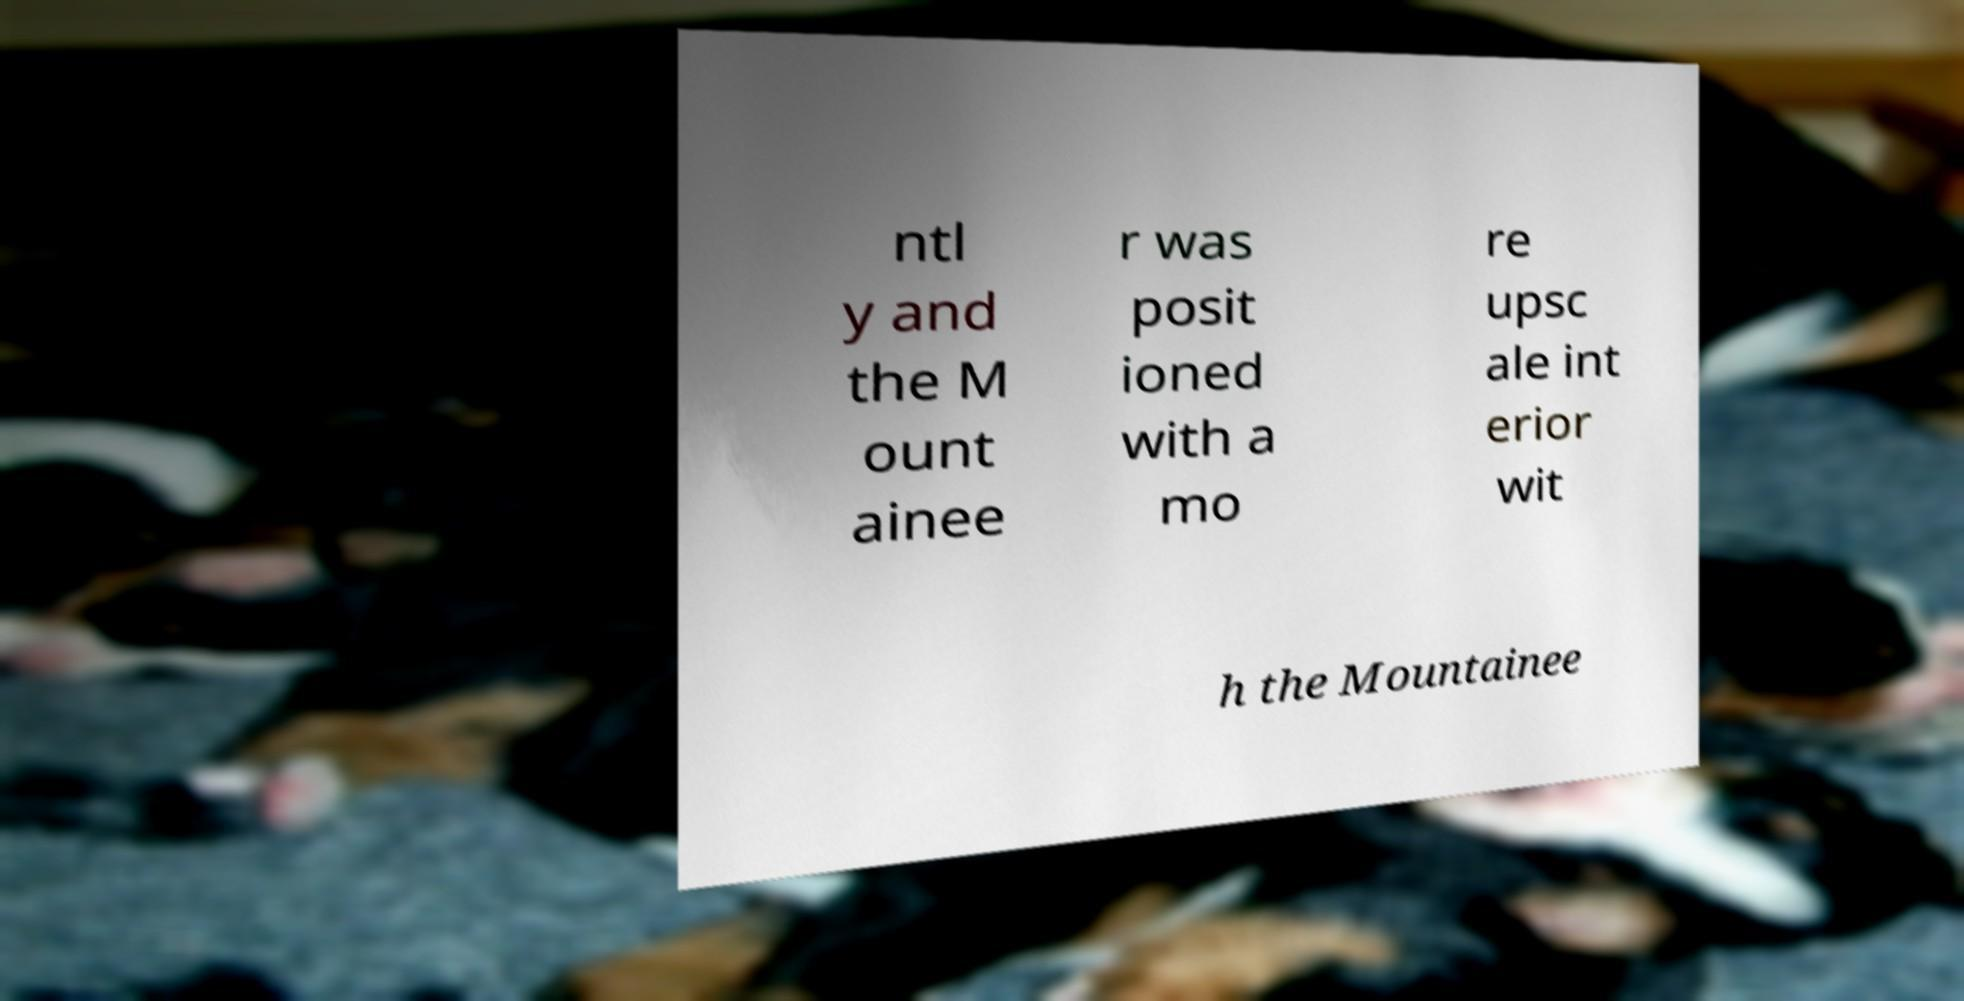Please identify and transcribe the text found in this image. ntl y and the M ount ainee r was posit ioned with a mo re upsc ale int erior wit h the Mountainee 